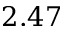Convert formula to latex. <formula><loc_0><loc_0><loc_500><loc_500>2 . 4 7</formula> 